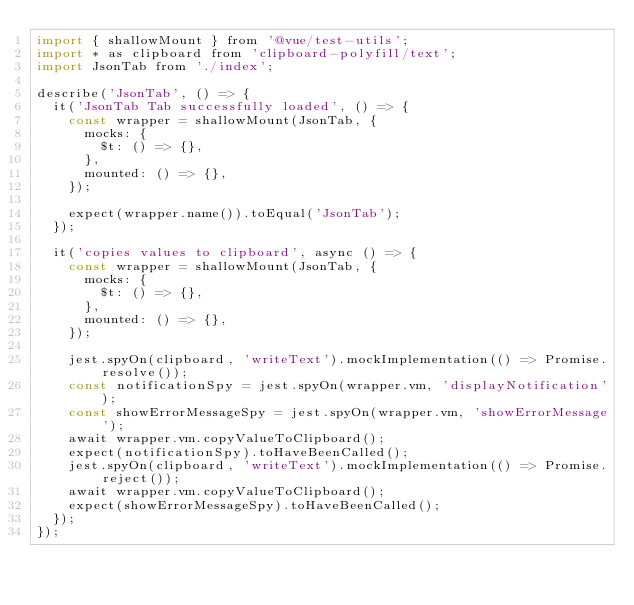Convert code to text. <code><loc_0><loc_0><loc_500><loc_500><_JavaScript_>import { shallowMount } from '@vue/test-utils';
import * as clipboard from 'clipboard-polyfill/text';
import JsonTab from './index';

describe('JsonTab', () => {
  it('JsonTab Tab successfully loaded', () => {
    const wrapper = shallowMount(JsonTab, {
      mocks: {
        $t: () => {},
      },
      mounted: () => {},
    });

    expect(wrapper.name()).toEqual('JsonTab');
  });

  it('copies values to clipboard', async () => {
    const wrapper = shallowMount(JsonTab, {
      mocks: {
        $t: () => {},
      },
      mounted: () => {},
    });

    jest.spyOn(clipboard, 'writeText').mockImplementation(() => Promise.resolve());
    const notificationSpy = jest.spyOn(wrapper.vm, 'displayNotification');
    const showErrorMessageSpy = jest.spyOn(wrapper.vm, 'showErrorMessage');
    await wrapper.vm.copyValueToClipboard();
    expect(notificationSpy).toHaveBeenCalled();
    jest.spyOn(clipboard, 'writeText').mockImplementation(() => Promise.reject());
    await wrapper.vm.copyValueToClipboard();
    expect(showErrorMessageSpy).toHaveBeenCalled();
  });
});
</code> 